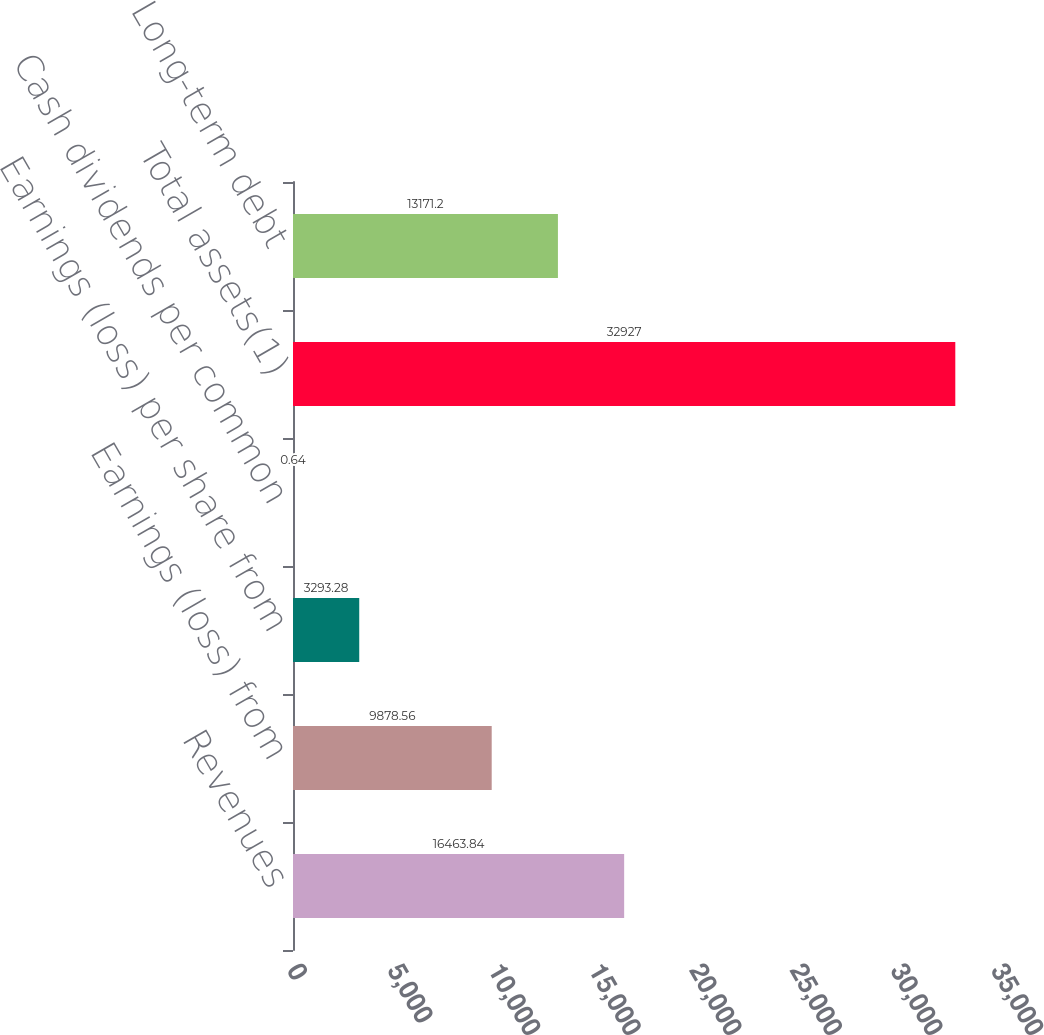Convert chart to OTSL. <chart><loc_0><loc_0><loc_500><loc_500><bar_chart><fcel>Revenues<fcel>Earnings (loss) from<fcel>Earnings (loss) per share from<fcel>Cash dividends per common<fcel>Total assets(1)<fcel>Long-term debt<nl><fcel>16463.8<fcel>9878.56<fcel>3293.28<fcel>0.64<fcel>32927<fcel>13171.2<nl></chart> 